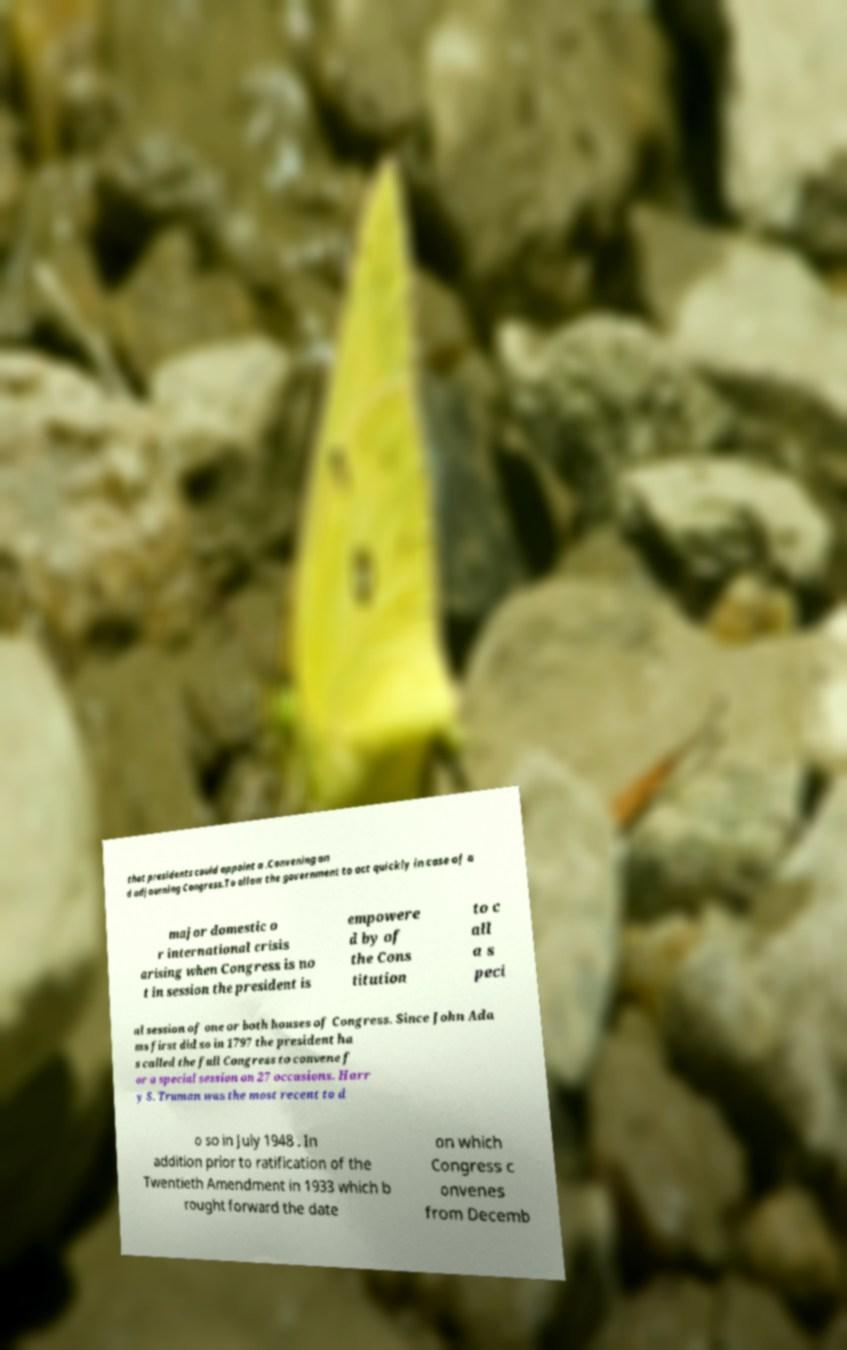Could you extract and type out the text from this image? that presidents could appoint a .Convening an d adjourning Congress.To allow the government to act quickly in case of a major domestic o r international crisis arising when Congress is no t in session the president is empowere d by of the Cons titution to c all a s peci al session of one or both houses of Congress. Since John Ada ms first did so in 1797 the president ha s called the full Congress to convene f or a special session on 27 occasions. Harr y S. Truman was the most recent to d o so in July 1948 . In addition prior to ratification of the Twentieth Amendment in 1933 which b rought forward the date on which Congress c onvenes from Decemb 